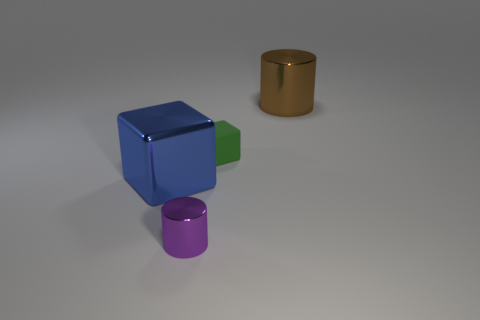Add 4 green objects. How many objects exist? 8 Subtract 0 gray blocks. How many objects are left? 4 Subtract all large blue blocks. Subtract all green rubber objects. How many objects are left? 2 Add 2 shiny cubes. How many shiny cubes are left? 3 Add 3 small green cubes. How many small green cubes exist? 4 